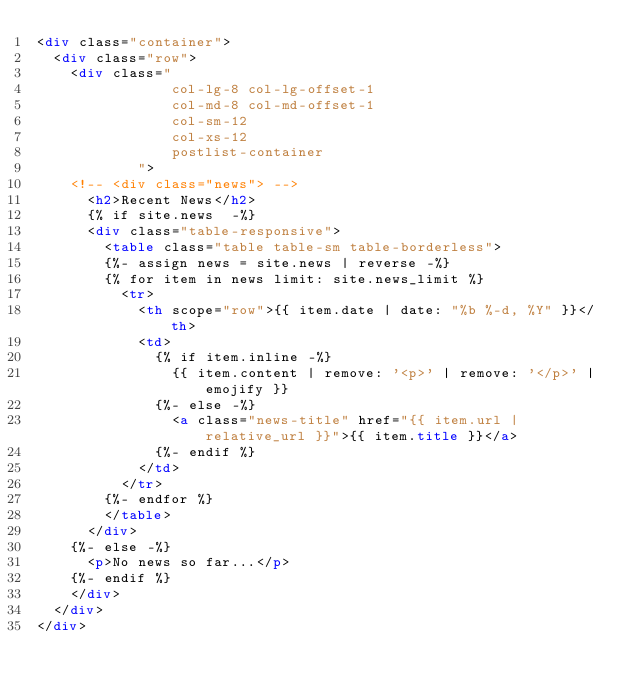Convert code to text. <code><loc_0><loc_0><loc_500><loc_500><_HTML_><div class="container">
  <div class="row">
    <div class="
                col-lg-8 col-lg-offset-1
                col-md-8 col-md-offset-1
                col-sm-12
                col-xs-12
                postlist-container
            ">
    <!-- <div class="news"> -->
      <h2>Recent News</h2>
      {% if site.news  -%} 
      <div class="table-responsive">
        <table class="table table-sm table-borderless">
        {%- assign news = site.news | reverse -%} 
        {% for item in news limit: site.news_limit %} 
          <tr>
            <th scope="row">{{ item.date | date: "%b %-d, %Y" }}</th>
            <td>
              {% if item.inline -%} 
                {{ item.content | remove: '<p>' | remove: '</p>' | emojify }}
              {%- else -%} 
                <a class="news-title" href="{{ item.url | relative_url }}">{{ item.title }}</a>
              {%- endif %} 
            </td>
          </tr>
        {%- endfor %} 
        </table>
      </div>
    {%- else -%} 
      <p>No news so far...</p>
    {%- endif %} 
    </div>
  </div>
</div>
</code> 